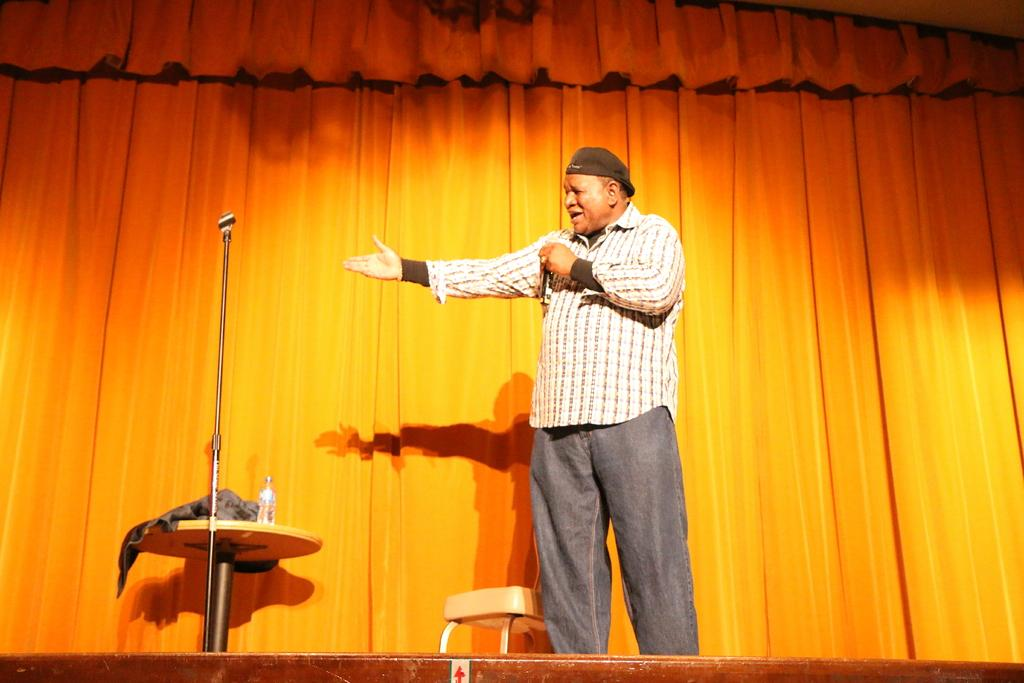What is the man in the image doing? The man is holding a mic in his hand and talking. What object is the man holding in the image? The man is holding a mic in his hand. What furniture is present in the image? There is a chair and a table in the image. What is on the table in the image? There is a bottle on the table. What can be seen in the background of the image? There is a curtain in the background of the image. Can you see any railways in the image? There are no railways present in the image. Is there a hose visible in the image? There is no hose visible in the image. 